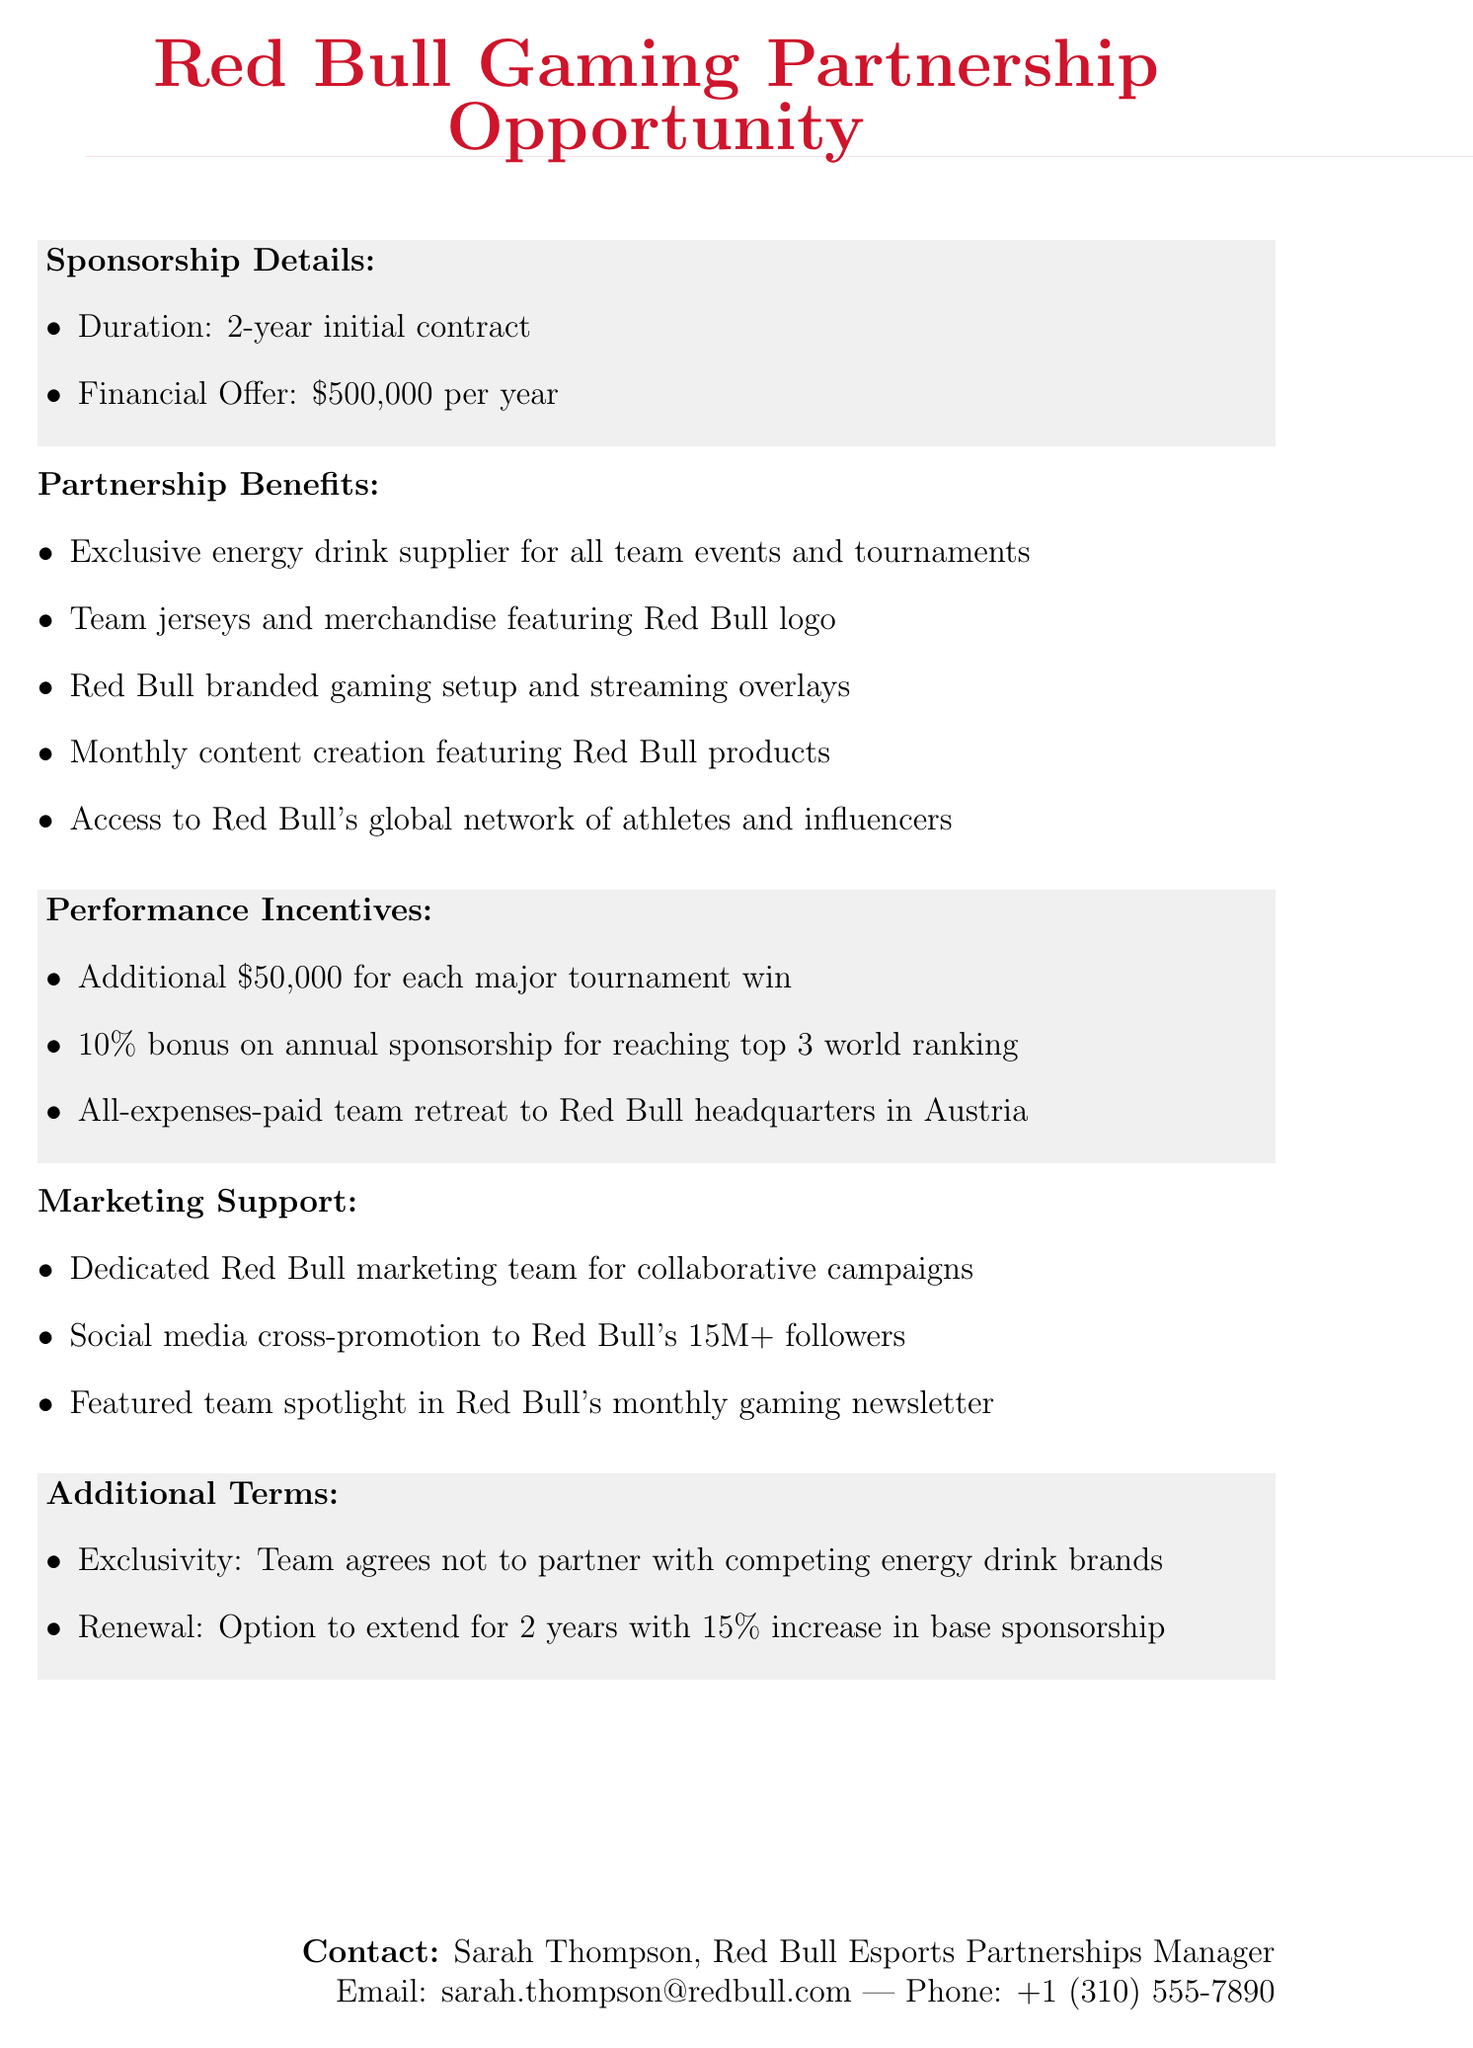what is the name of the sponsoring company? The document specifies that the company proposing the partnership is Red Bull.
Answer: Red Bull what is the financial offer per year? The financial offer outlined in the proposal is $500,000 per year.
Answer: $500,000 per year how long is the initial contract duration? The document states the duration of the initial contract is 2 years.
Answer: 2 years what is one of the performance incentives for winning major tournaments? The document mentions that the team will receive an additional $50,000 for each major tournament win.
Answer: $50,000 for each major tournament win what type of marketing support is provided? The document lists the support as a dedicated Red Bull marketing team for collaborative campaigns.
Answer: Dedicated Red Bull marketing team what is the exclusivity clause in the contract? The document requires that the team agrees not to partner with competing energy drink brands.
Answer: Not to partner with competing energy drink brands who is the contact person for the sponsorship proposal? The document specifies that the contact person is Sarah Thompson.
Answer: Sarah Thompson what is the bonus percentage for reaching the top 3 world ranking? The proposal states that there is a 10% bonus on the annual sponsorship for achieving this ranking.
Answer: 10% bonus what happens after the initial contract period ends? The document states that there is an option to extend the partnership for an additional 2 years.
Answer: Option to extend for 2 years 